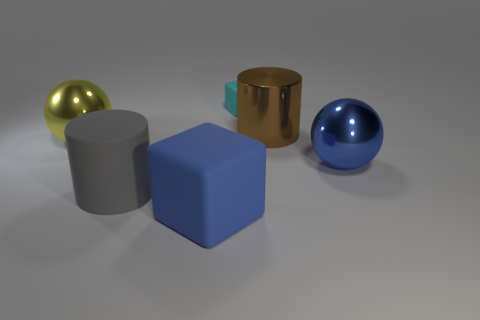What is the color of the metallic object that is both in front of the brown shiny cylinder and right of the big yellow shiny ball? The metallic object located in front of the brown shiny cylinder and to the right of the large yellow shiny ball is blue, with a smooth surface that reflects the light around it, giving it a lustrous appearance. 